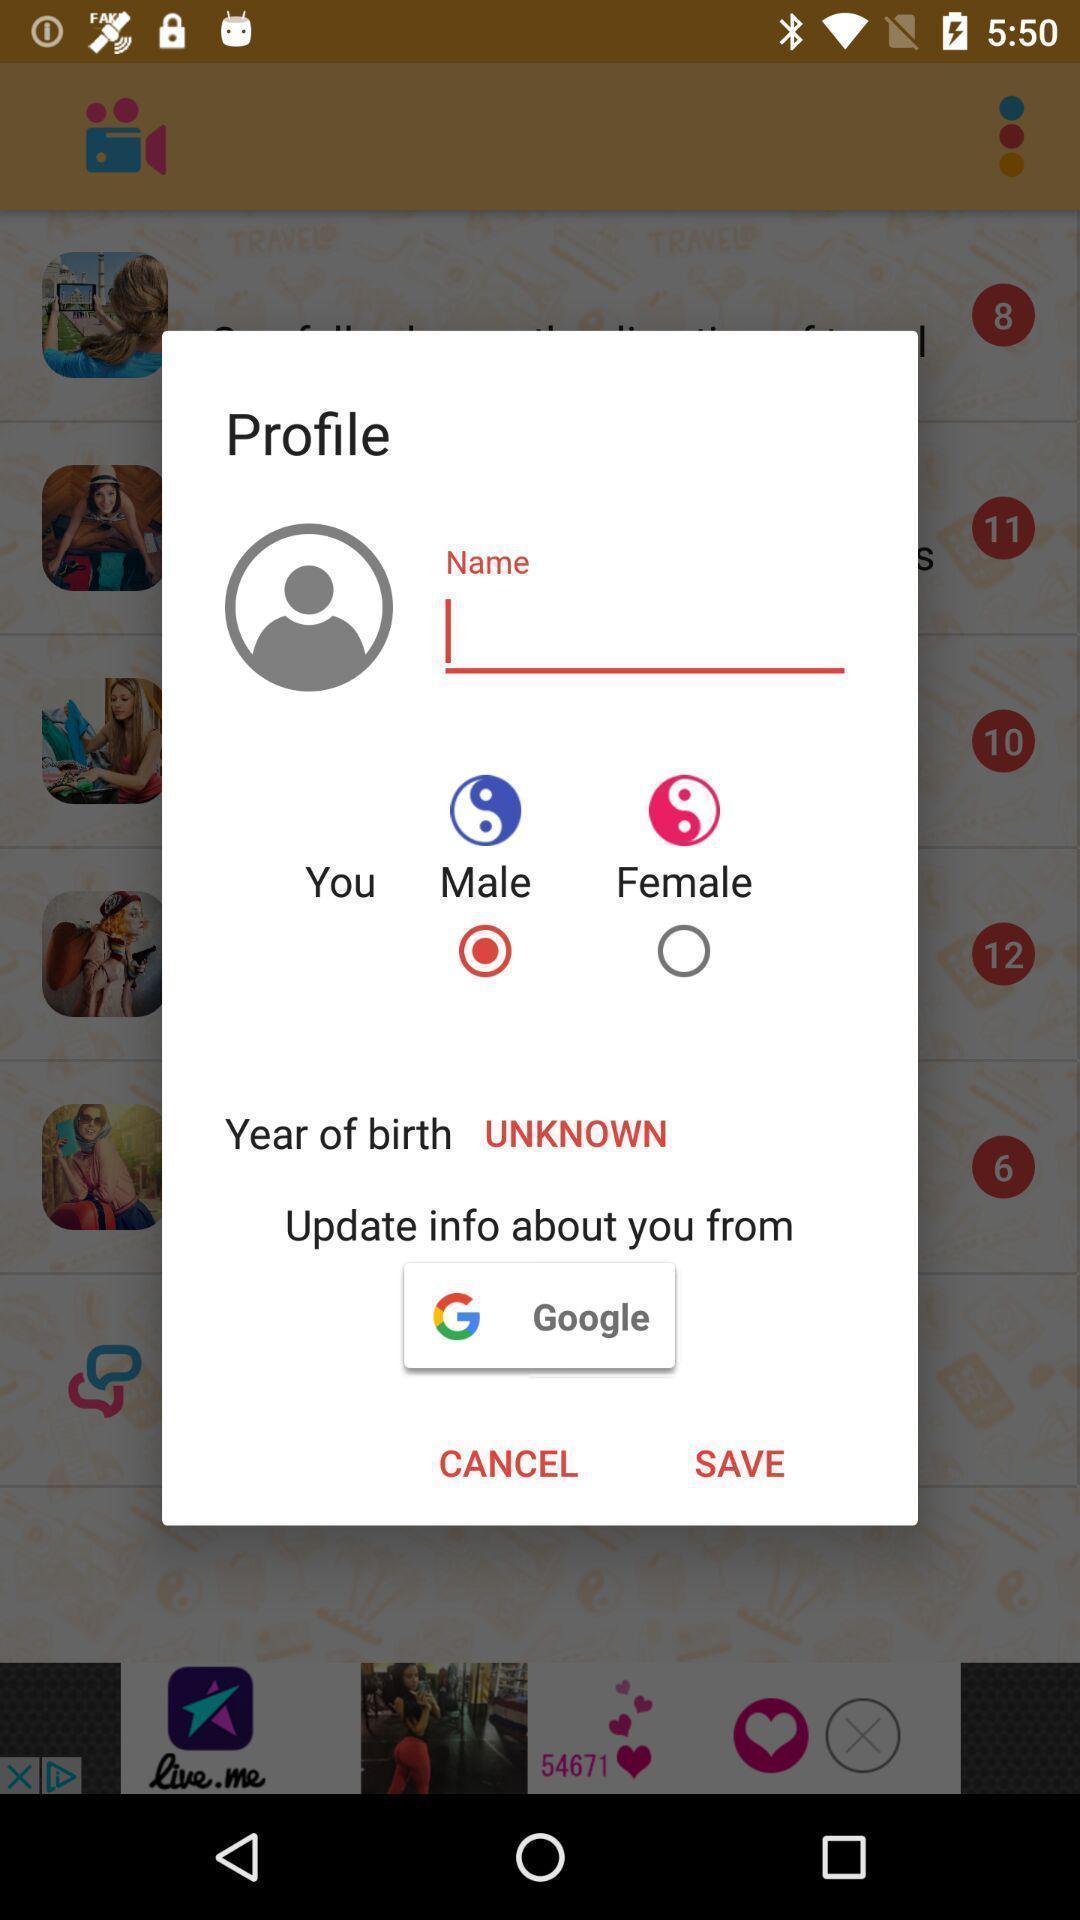What is the overall content of this screenshot? Pop up window to set profile. 